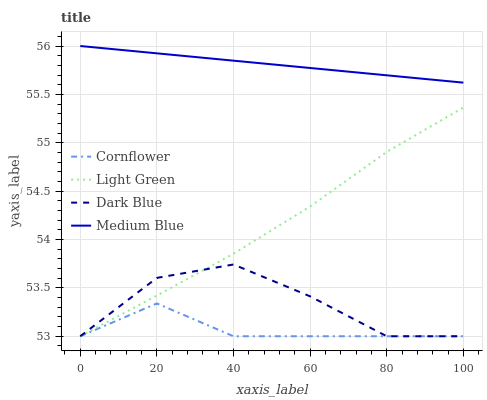Does Light Green have the minimum area under the curve?
Answer yes or no. No. Does Light Green have the maximum area under the curve?
Answer yes or no. No. Is Light Green the smoothest?
Answer yes or no. No. Is Light Green the roughest?
Answer yes or no. No. Does Medium Blue have the lowest value?
Answer yes or no. No. Does Light Green have the highest value?
Answer yes or no. No. Is Cornflower less than Medium Blue?
Answer yes or no. Yes. Is Medium Blue greater than Dark Blue?
Answer yes or no. Yes. Does Cornflower intersect Medium Blue?
Answer yes or no. No. 